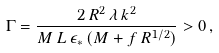Convert formula to latex. <formula><loc_0><loc_0><loc_500><loc_500>\Gamma = \frac { 2 \, R ^ { 2 } \, \lambda \, k ^ { 2 } } { M \, L \, \epsilon _ { \ast } \, ( M + f \, R ^ { 1 / 2 } ) } > 0 \, ,</formula> 